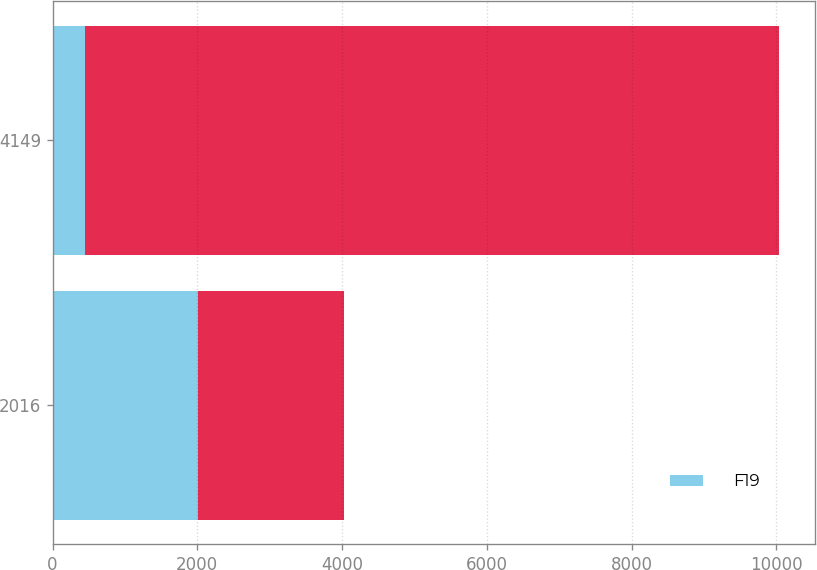<chart> <loc_0><loc_0><loc_500><loc_500><stacked_bar_chart><ecel><fcel>2016<fcel>4149<nl><fcel>F19<fcel>2015<fcel>442<nl><fcel>nan<fcel>2014<fcel>9590<nl></chart> 